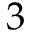<formula> <loc_0><loc_0><loc_500><loc_500>3</formula> 